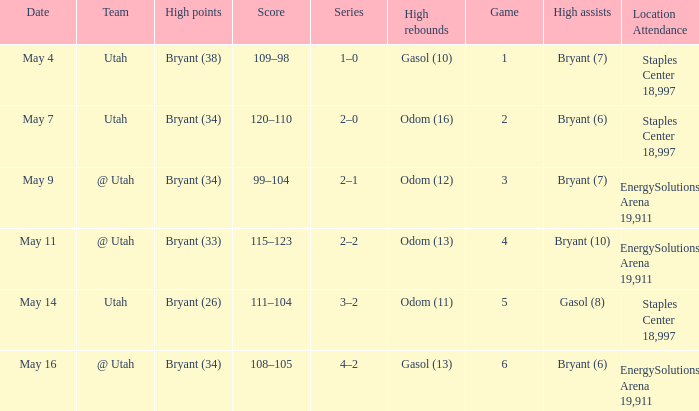What is the Series with a High rebounds with gasol (10)? 1–0. 